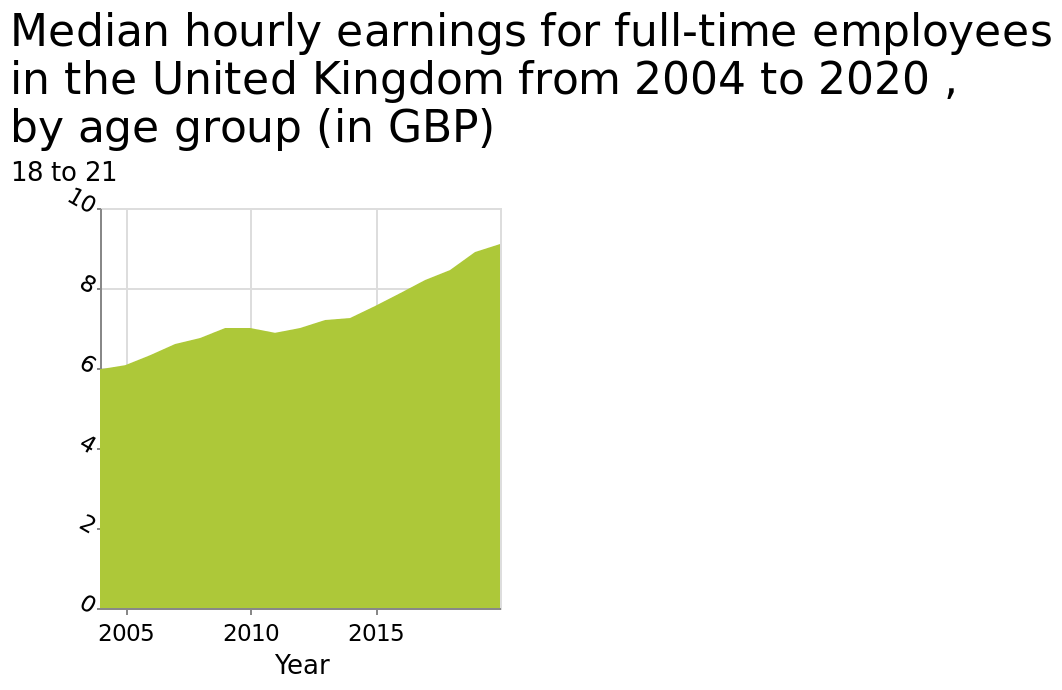<image>
What does the y-axis of the graph represent? The y-axis of the graph represents the median hourly earnings for full-time employees in GBP. What does the x-axis of the graph represent? The x-axis of the graph represents the years from 2004 to 2020. What has happened to median hourly earnings over the years?  Median hourly earnings have increased. please summary the statistics and relations of the chart Hourly earnings in the 18-21 age range have steadily increased between 2005 to 2020.  Over the 14 year period the average hourly wage for a full time worker has increased by 50%. Describe the following image in detail Median hourly earnings for full-time employees in the United Kingdom from 2004 to 2020 , by age group (in GBP) is a area graph. The y-axis measures 18 to 21 on linear scale with a minimum of 0 and a maximum of 10 while the x-axis shows Year along linear scale with a minimum of 2005 and a maximum of 2015. 